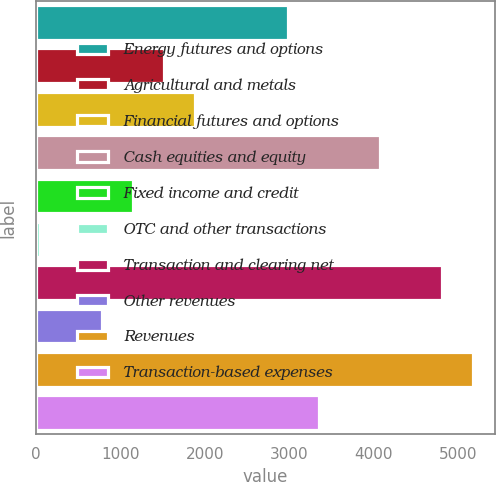Convert chart. <chart><loc_0><loc_0><loc_500><loc_500><bar_chart><fcel>Energy futures and options<fcel>Agricultural and metals<fcel>Financial futures and options<fcel>Cash equities and equity<fcel>Fixed income and credit<fcel>OTC and other transactions<fcel>Transaction and clearing net<fcel>Other revenues<fcel>Revenues<fcel>Transaction-based expenses<nl><fcel>2983.4<fcel>1516.2<fcel>1883<fcel>4083.8<fcel>1149.4<fcel>49<fcel>4817.4<fcel>782.6<fcel>5184.2<fcel>3350.2<nl></chart> 